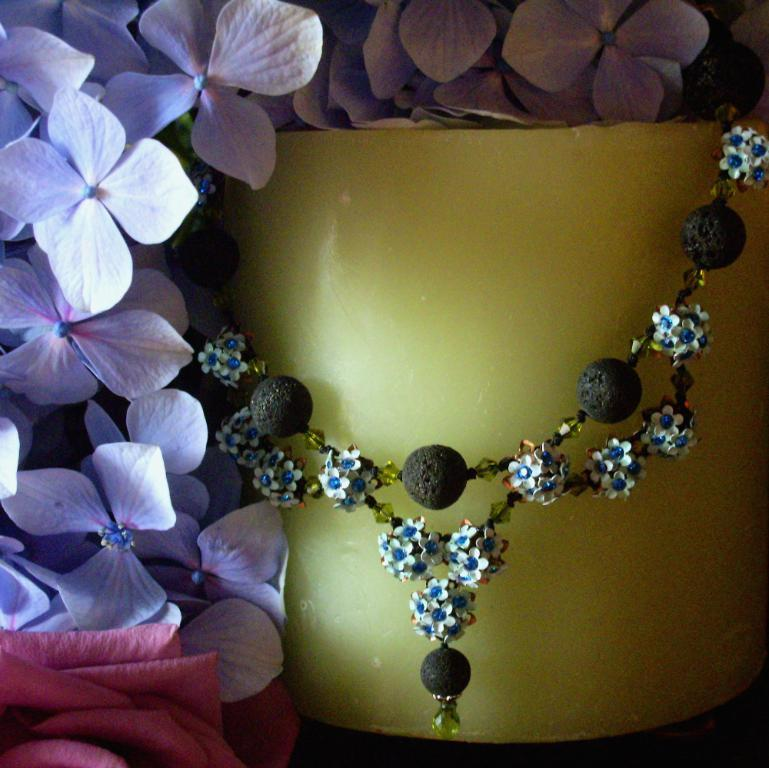What type of living organisms can be seen in the image? There are flowers in the image. What additional object can be seen in the image? There is an ornament in the image. What type of prison can be seen in the image? There is no prison present in the image; it features flowers and an ornament. How does the muscle appear in the image? There is no muscle present in the image. 